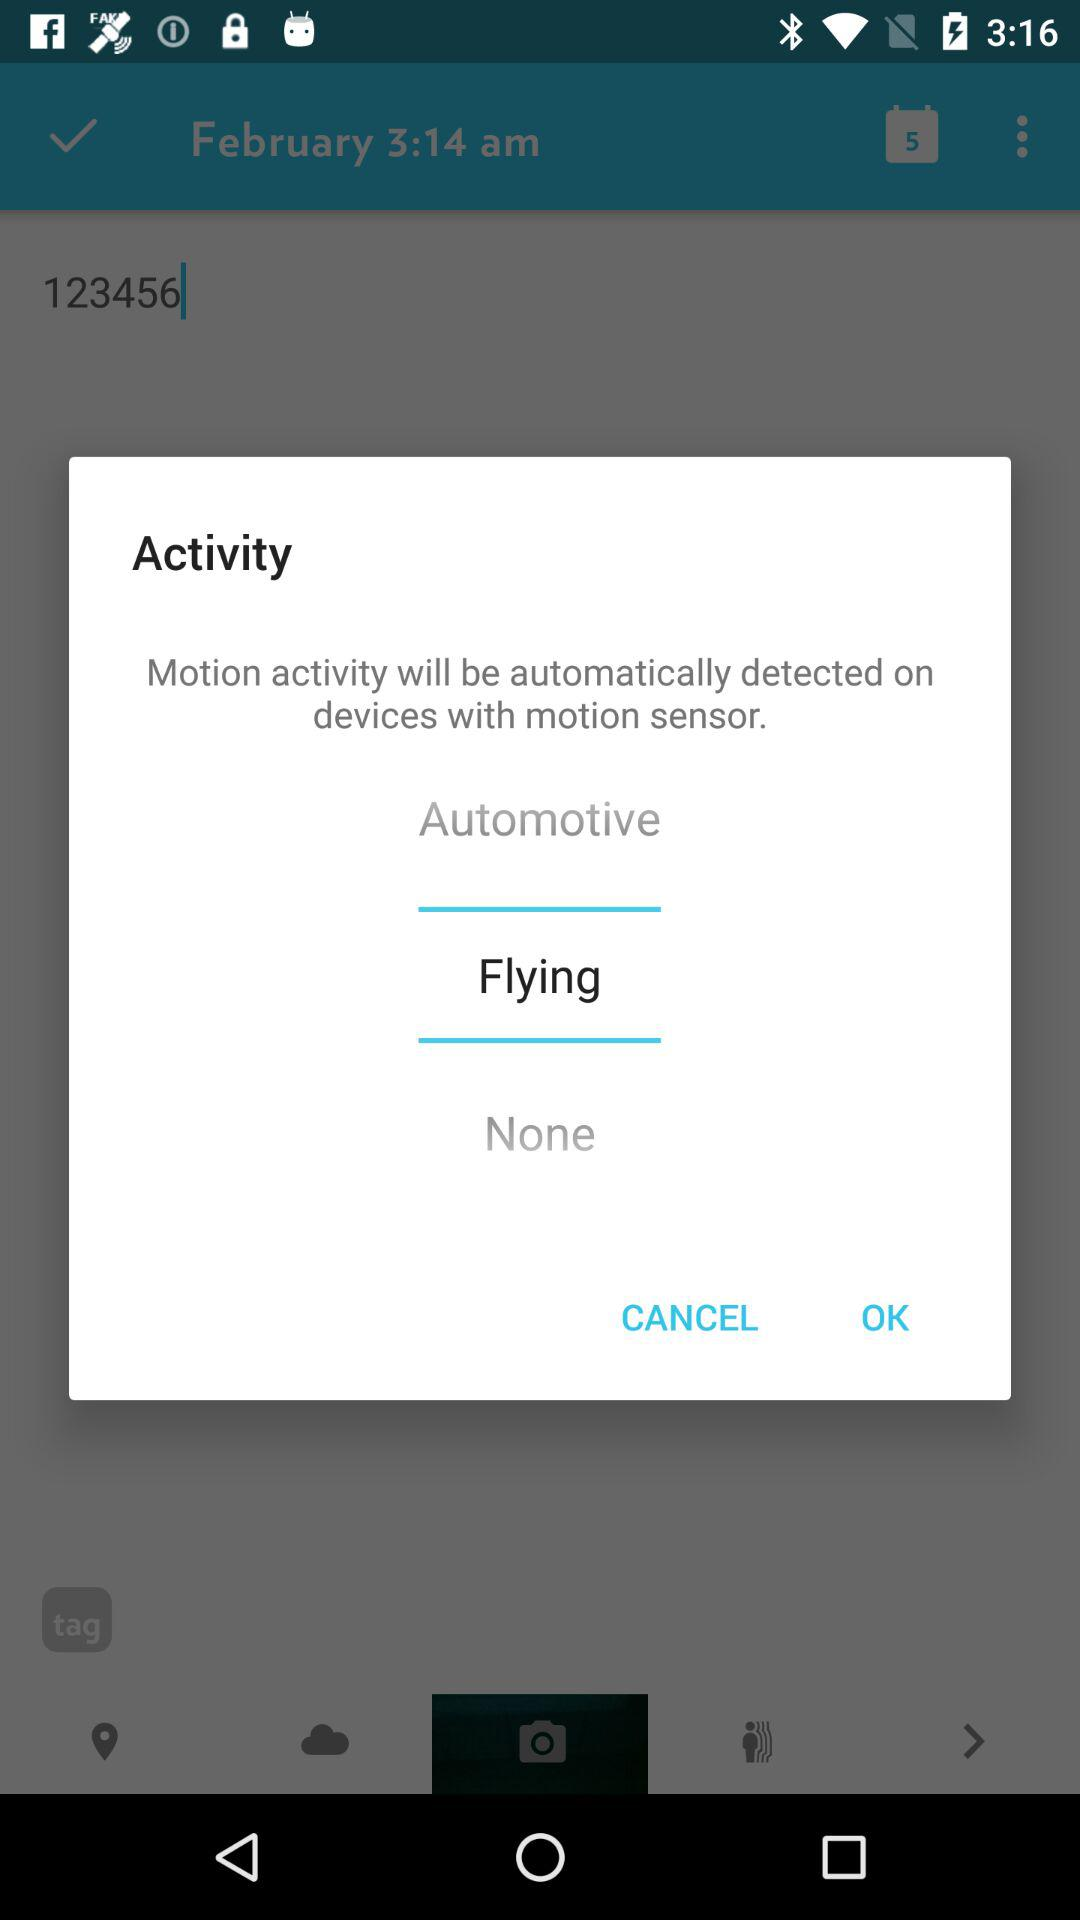What is the mentioned time? The mentioned time is 3:14 a.m. 